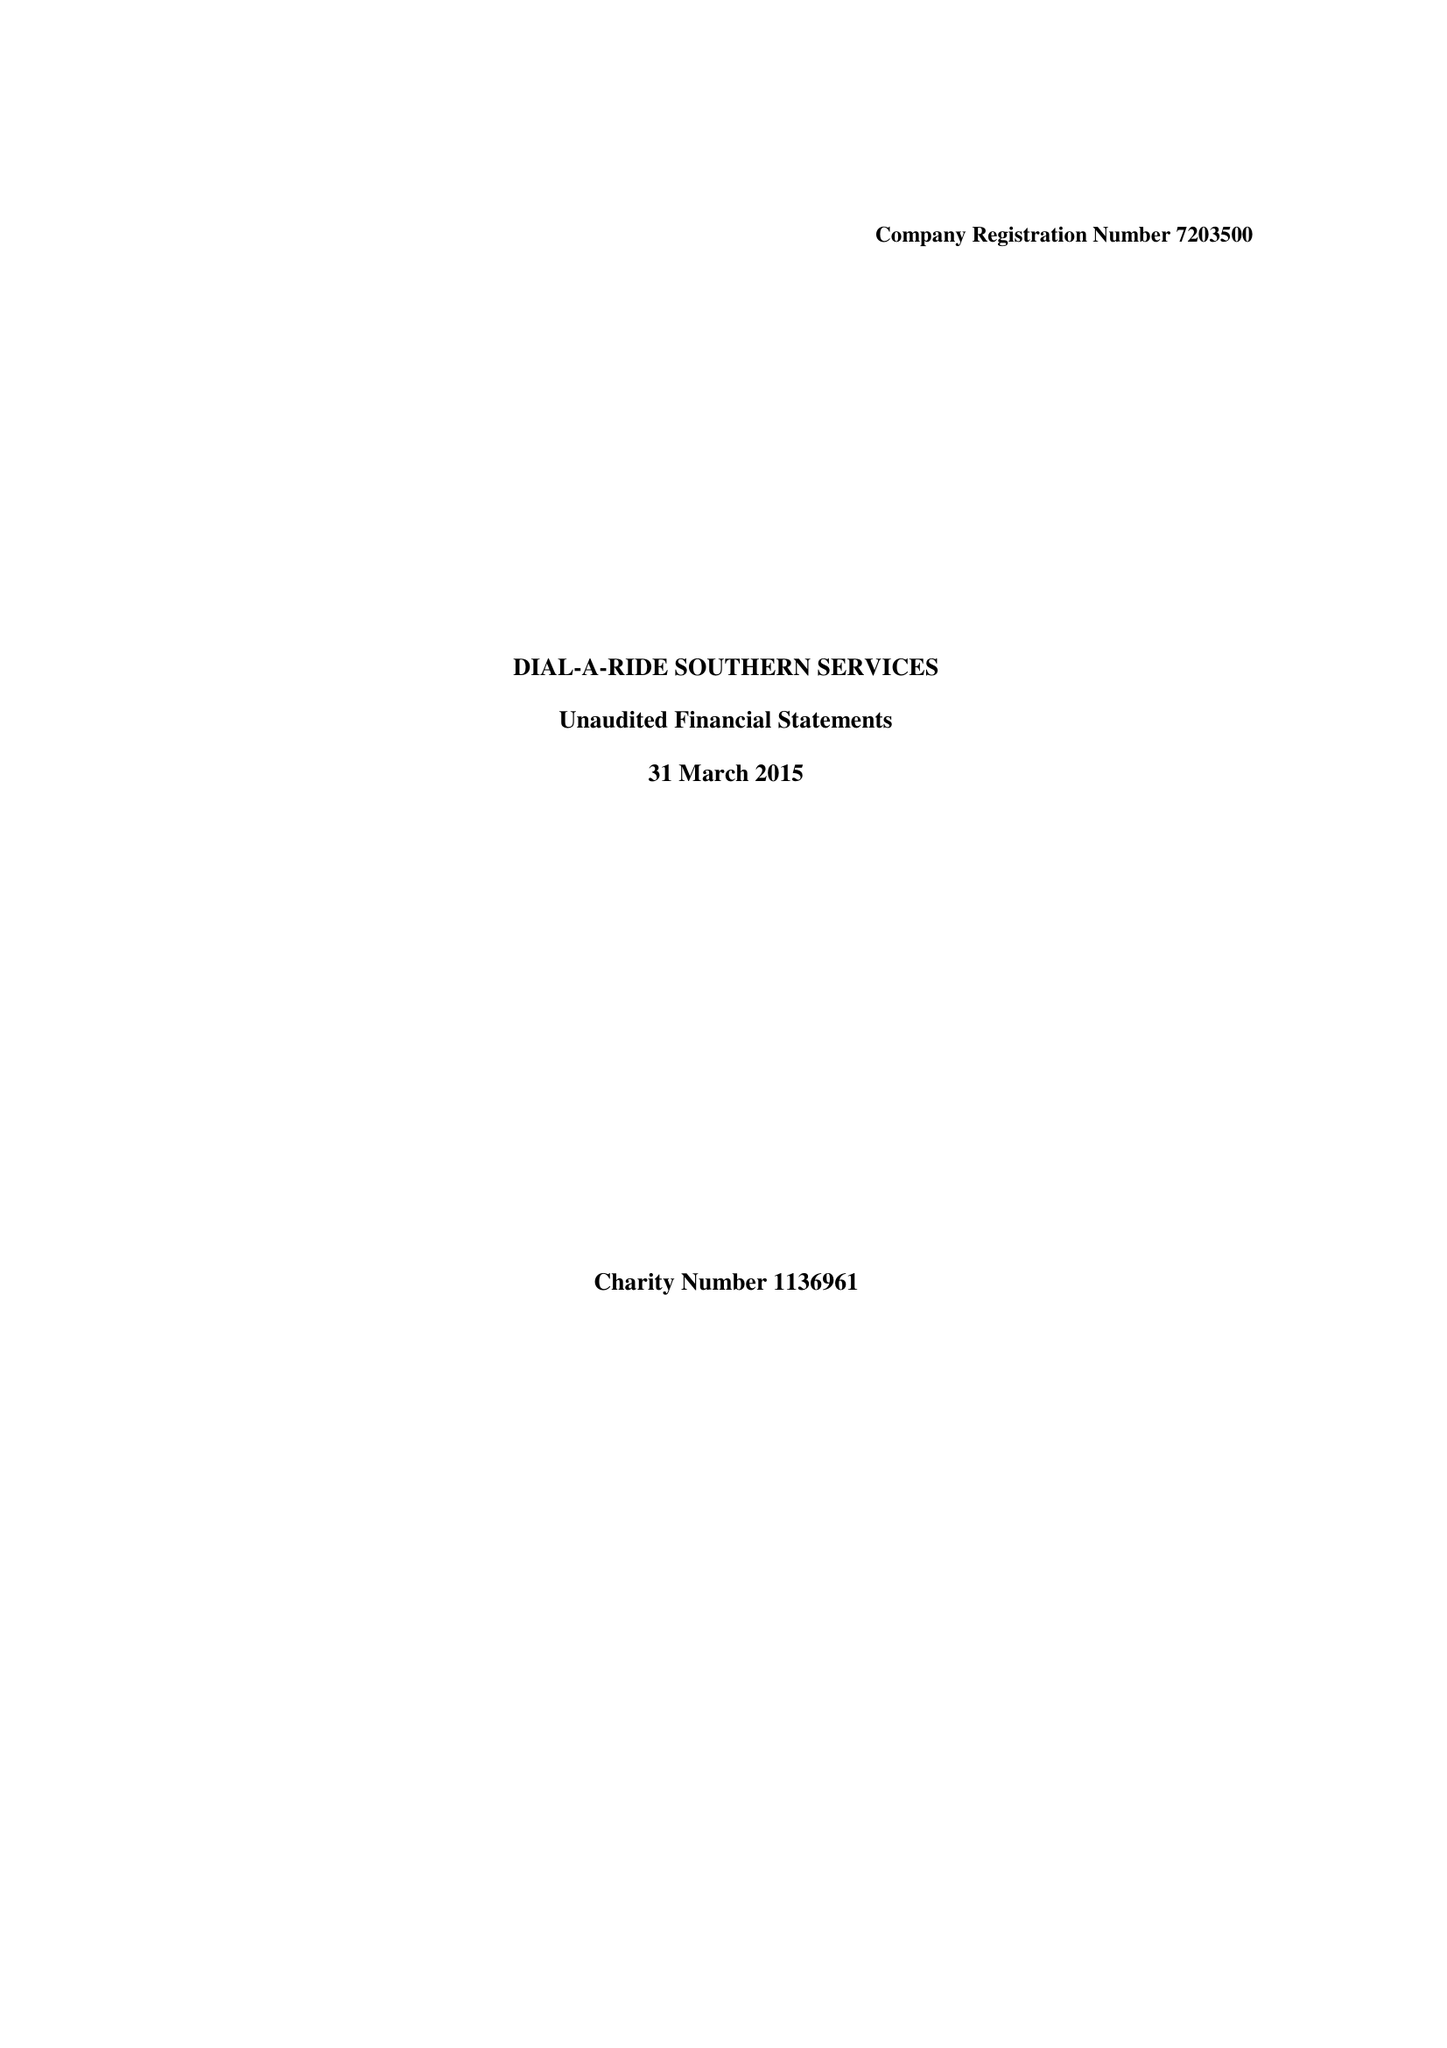What is the value for the income_annually_in_british_pounds?
Answer the question using a single word or phrase. 99949.00 